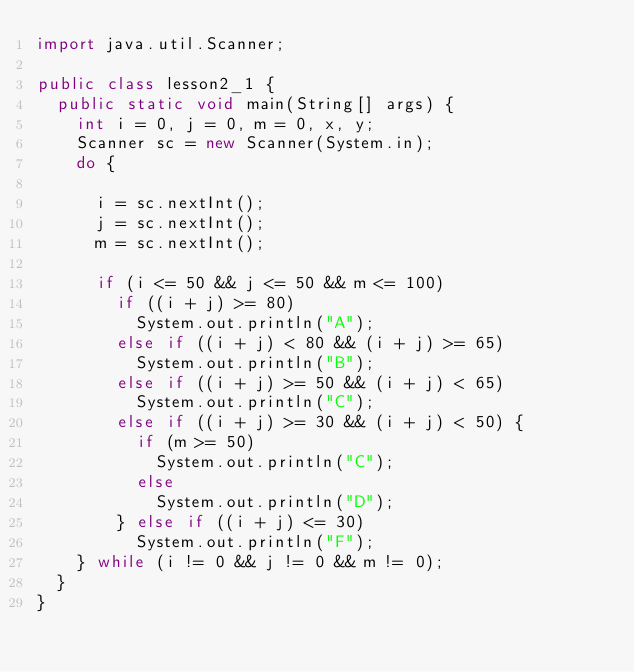Convert code to text. <code><loc_0><loc_0><loc_500><loc_500><_Java_>import java.util.Scanner;

public class lesson2_1 {
	public static void main(String[] args) {
		int i = 0, j = 0, m = 0, x, y;
		Scanner sc = new Scanner(System.in);
		do {

			i = sc.nextInt();
			j = sc.nextInt();
			m = sc.nextInt();

			if (i <= 50 && j <= 50 && m <= 100)
				if ((i + j) >= 80)
					System.out.println("A");
				else if ((i + j) < 80 && (i + j) >= 65)
					System.out.println("B");
				else if ((i + j) >= 50 && (i + j) < 65)
					System.out.println("C");
				else if ((i + j) >= 30 && (i + j) < 50) {
					if (m >= 50)
						System.out.println("C");
					else
						System.out.println("D");
				} else if ((i + j) <= 30)
					System.out.println("F");
		} while (i != 0 && j != 0 && m != 0);
	}
}</code> 